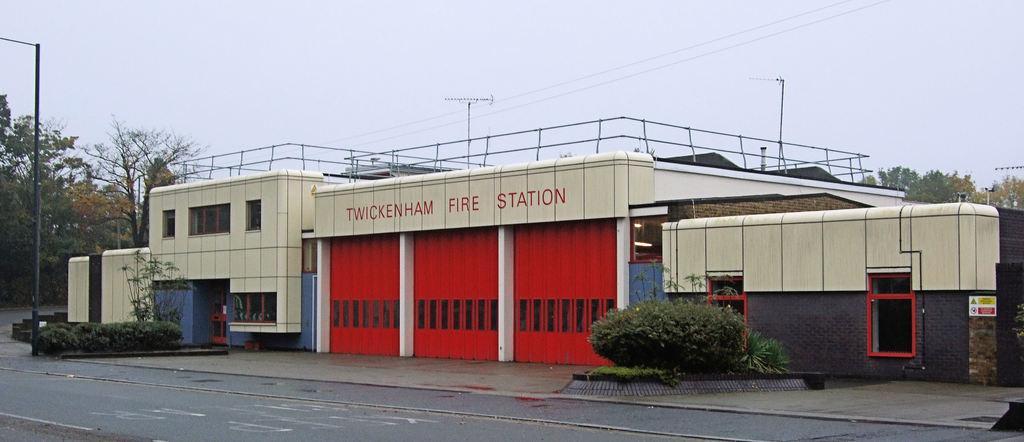Can you describe this image briefly? In this picture there is a building. Here we can see plants and street lights. In the background we can see many trees. On the top we can see sky and clouds. Here we can see some electrical wires. On the bottom there is a road. Here we can see grass. 